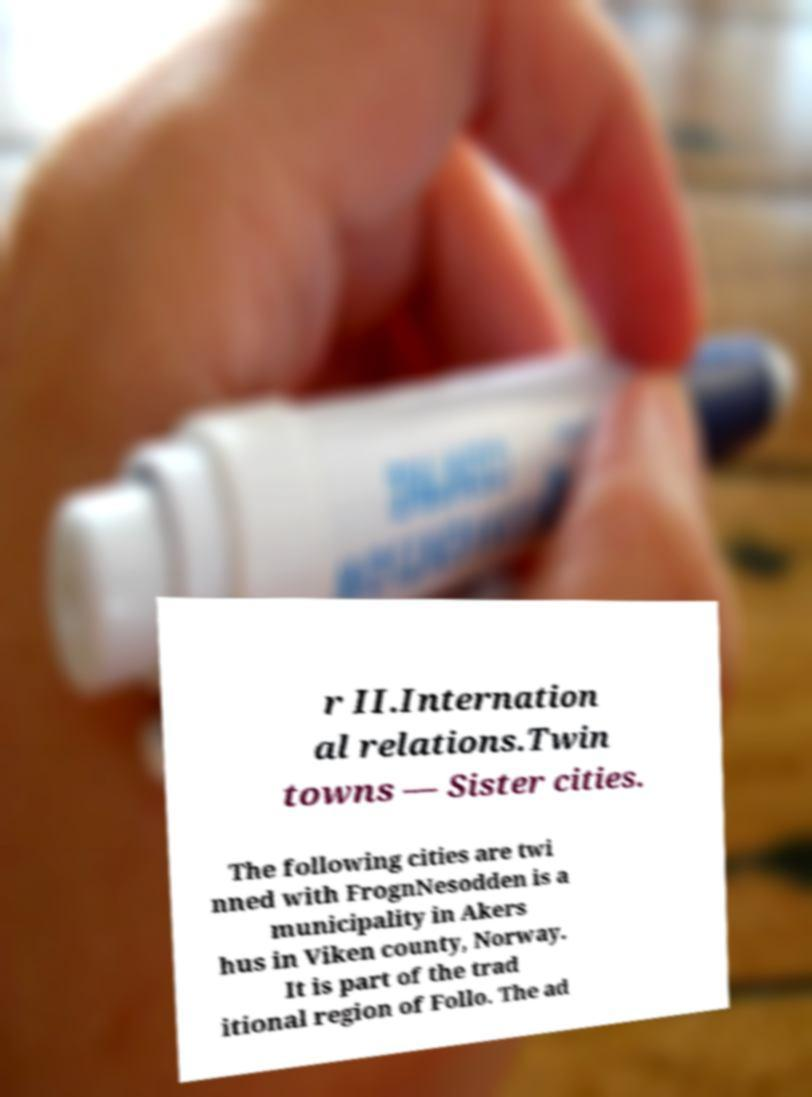Can you accurately transcribe the text from the provided image for me? r II.Internation al relations.Twin towns — Sister cities. The following cities are twi nned with FrognNesodden is a municipality in Akers hus in Viken county, Norway. It is part of the trad itional region of Follo. The ad 